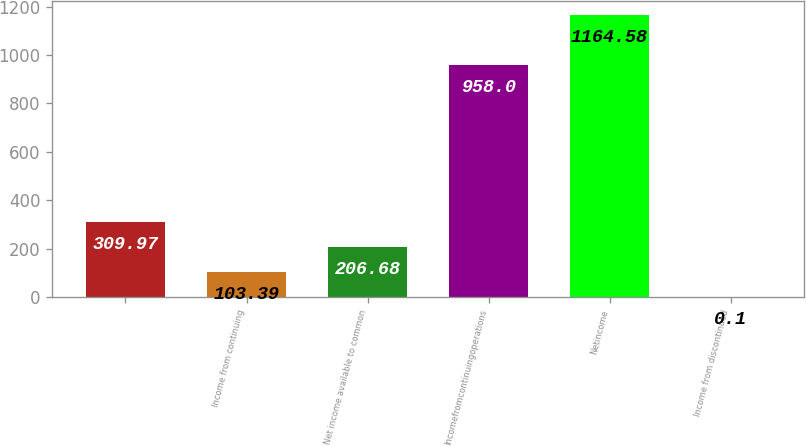<chart> <loc_0><loc_0><loc_500><loc_500><bar_chart><ecel><fcel>Income from continuing<fcel>Net income available to common<fcel>Incomefromcontinuingoperations<fcel>Netincome<fcel>Income from discontinued<nl><fcel>309.97<fcel>103.39<fcel>206.68<fcel>958<fcel>1164.58<fcel>0.1<nl></chart> 